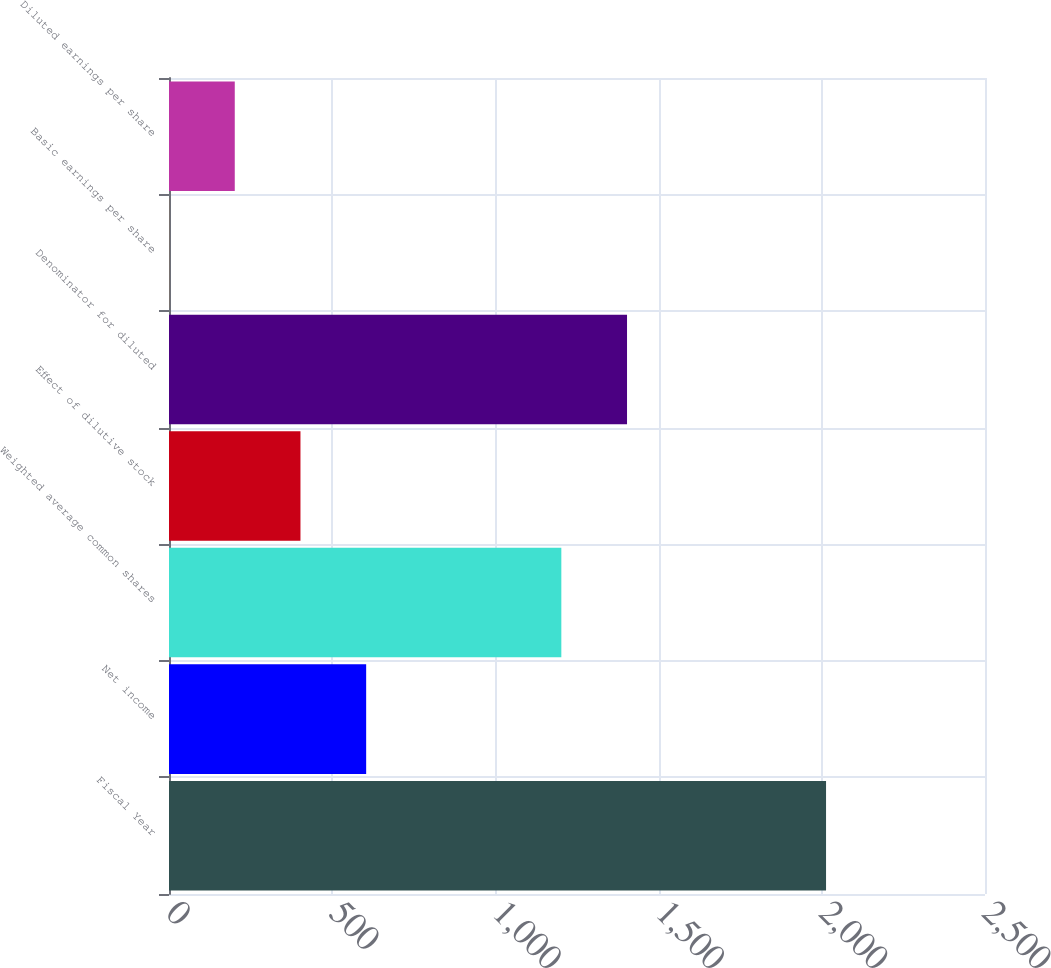<chart> <loc_0><loc_0><loc_500><loc_500><bar_chart><fcel>Fiscal Year<fcel>Net income<fcel>Weighted average common shares<fcel>Effect of dilutive stock<fcel>Denominator for diluted<fcel>Basic earnings per share<fcel>Diluted earnings per share<nl><fcel>2013<fcel>604.05<fcel>1202<fcel>402.77<fcel>1403.28<fcel>0.21<fcel>201.49<nl></chart> 